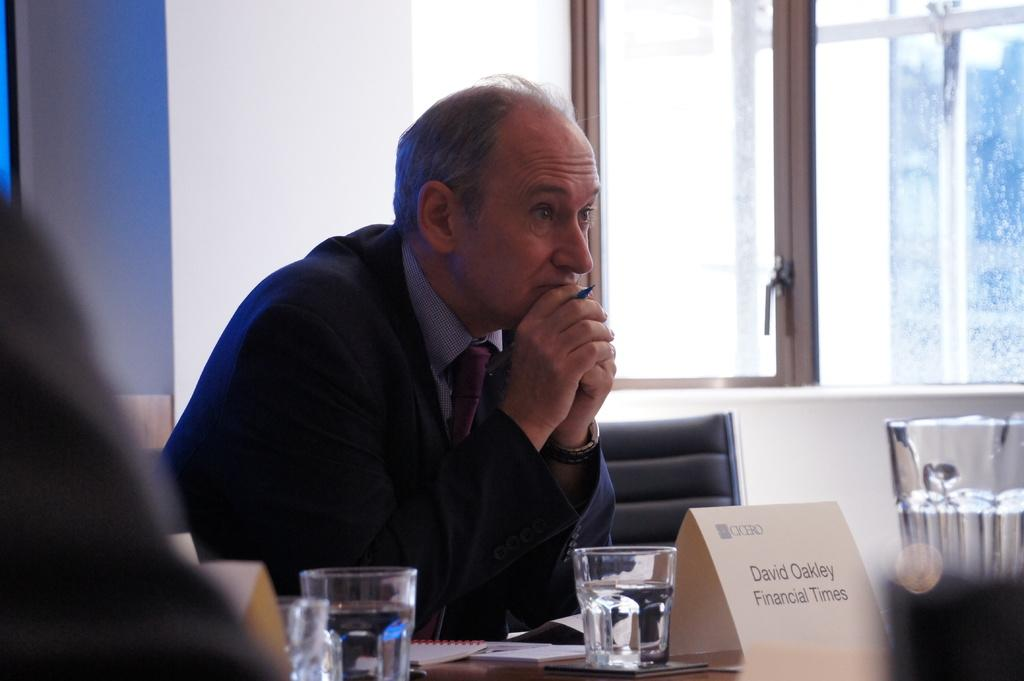<image>
Provide a brief description of the given image. A table with glasses of water reserved for David Oakley Financial TImes. 